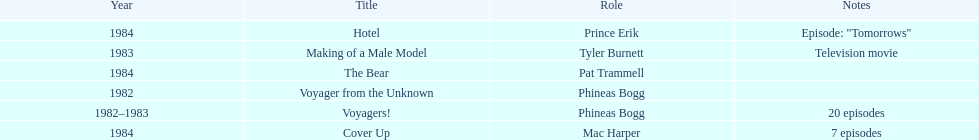Which year did he play the role of mac harper and also pat trammell? 1984. 